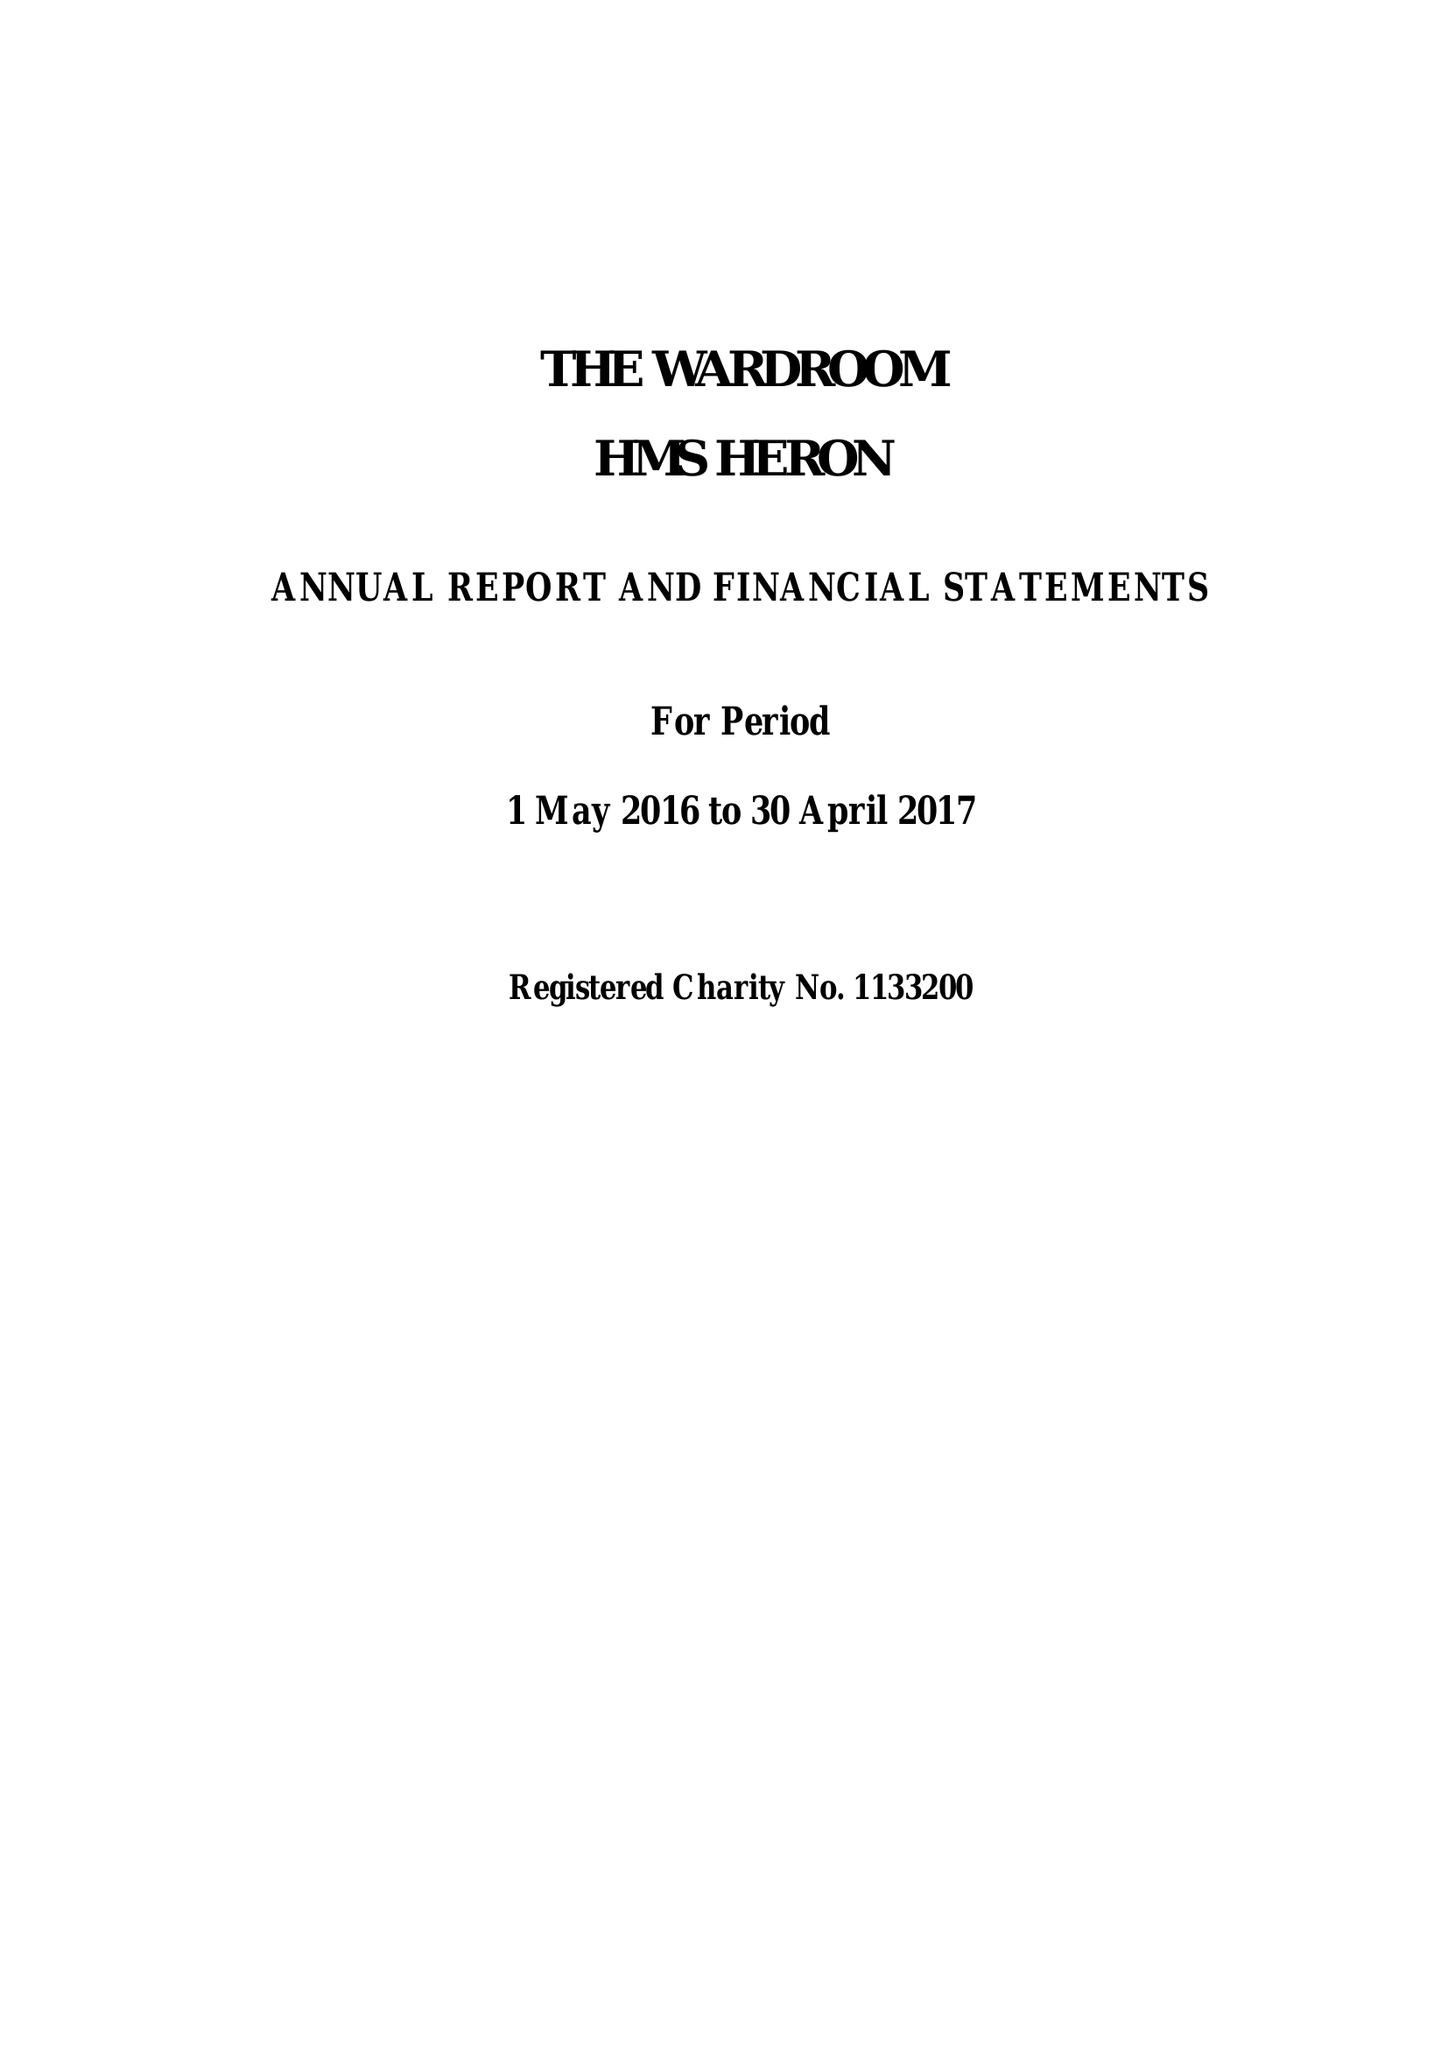What is the value for the report_date?
Answer the question using a single word or phrase. 2017-04-30 